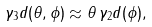<formula> <loc_0><loc_0><loc_500><loc_500>\gamma _ { 3 } d ( \theta , \phi ) \approx \theta \, \gamma _ { 2 } d ( \phi ) ,</formula> 